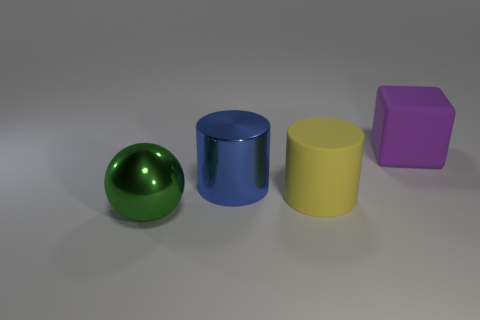What might the purpose of these objects be, and do they look like they are part of a set? These objects appear to be simple geometric shapes, often used as visual tools for educational purposes, like teaching about shapes and colors. Each object has a distinct color and shape, which could be useful for differentiating them in a learning environment. They do seem to form a cohesive set, given their similar style and the consistencies in their appearances, suggesting they were created as a collection for instruction or display. 